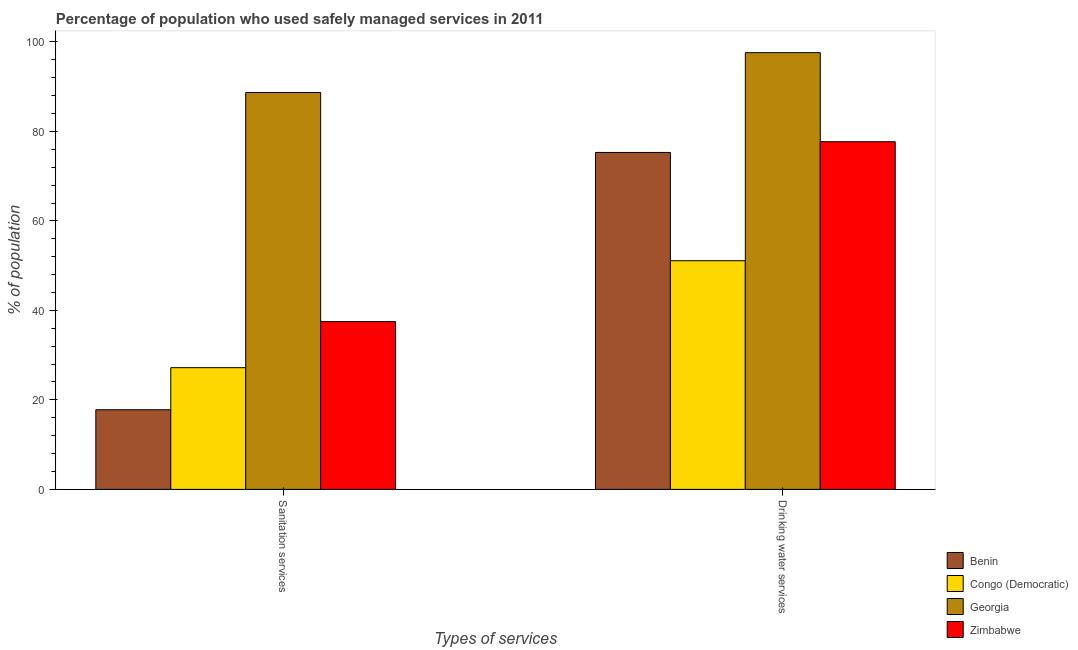Are the number of bars per tick equal to the number of legend labels?
Offer a terse response. Yes. Are the number of bars on each tick of the X-axis equal?
Ensure brevity in your answer.  Yes. How many bars are there on the 1st tick from the left?
Provide a succinct answer. 4. What is the label of the 2nd group of bars from the left?
Offer a terse response. Drinking water services. What is the percentage of population who used sanitation services in Congo (Democratic)?
Give a very brief answer. 27.2. Across all countries, what is the maximum percentage of population who used sanitation services?
Provide a short and direct response. 88.7. In which country was the percentage of population who used sanitation services maximum?
Your answer should be compact. Georgia. In which country was the percentage of population who used drinking water services minimum?
Your response must be concise. Congo (Democratic). What is the total percentage of population who used drinking water services in the graph?
Offer a very short reply. 301.7. What is the difference between the percentage of population who used drinking water services in Congo (Democratic) and that in Georgia?
Offer a very short reply. -46.5. What is the difference between the percentage of population who used sanitation services in Zimbabwe and the percentage of population who used drinking water services in Congo (Democratic)?
Keep it short and to the point. -13.6. What is the average percentage of population who used sanitation services per country?
Offer a very short reply. 42.8. What is the difference between the percentage of population who used drinking water services and percentage of population who used sanitation services in Zimbabwe?
Your answer should be very brief. 40.2. In how many countries, is the percentage of population who used sanitation services greater than 52 %?
Make the answer very short. 1. What is the ratio of the percentage of population who used drinking water services in Congo (Democratic) to that in Georgia?
Offer a terse response. 0.52. Is the percentage of population who used sanitation services in Congo (Democratic) less than that in Georgia?
Ensure brevity in your answer.  Yes. What does the 2nd bar from the left in Drinking water services represents?
Your response must be concise. Congo (Democratic). What does the 4th bar from the right in Sanitation services represents?
Make the answer very short. Benin. What is the difference between two consecutive major ticks on the Y-axis?
Offer a very short reply. 20. Are the values on the major ticks of Y-axis written in scientific E-notation?
Offer a terse response. No. Does the graph contain any zero values?
Give a very brief answer. No. How are the legend labels stacked?
Make the answer very short. Vertical. What is the title of the graph?
Your response must be concise. Percentage of population who used safely managed services in 2011. Does "Sweden" appear as one of the legend labels in the graph?
Your answer should be compact. No. What is the label or title of the X-axis?
Ensure brevity in your answer.  Types of services. What is the label or title of the Y-axis?
Keep it short and to the point. % of population. What is the % of population in Benin in Sanitation services?
Your answer should be very brief. 17.8. What is the % of population of Congo (Democratic) in Sanitation services?
Ensure brevity in your answer.  27.2. What is the % of population of Georgia in Sanitation services?
Offer a very short reply. 88.7. What is the % of population in Zimbabwe in Sanitation services?
Ensure brevity in your answer.  37.5. What is the % of population of Benin in Drinking water services?
Your response must be concise. 75.3. What is the % of population of Congo (Democratic) in Drinking water services?
Provide a succinct answer. 51.1. What is the % of population in Georgia in Drinking water services?
Your response must be concise. 97.6. What is the % of population in Zimbabwe in Drinking water services?
Your answer should be compact. 77.7. Across all Types of services, what is the maximum % of population in Benin?
Your response must be concise. 75.3. Across all Types of services, what is the maximum % of population in Congo (Democratic)?
Give a very brief answer. 51.1. Across all Types of services, what is the maximum % of population in Georgia?
Make the answer very short. 97.6. Across all Types of services, what is the maximum % of population of Zimbabwe?
Ensure brevity in your answer.  77.7. Across all Types of services, what is the minimum % of population of Benin?
Make the answer very short. 17.8. Across all Types of services, what is the minimum % of population of Congo (Democratic)?
Keep it short and to the point. 27.2. Across all Types of services, what is the minimum % of population of Georgia?
Provide a succinct answer. 88.7. Across all Types of services, what is the minimum % of population of Zimbabwe?
Offer a very short reply. 37.5. What is the total % of population of Benin in the graph?
Make the answer very short. 93.1. What is the total % of population in Congo (Democratic) in the graph?
Provide a short and direct response. 78.3. What is the total % of population in Georgia in the graph?
Keep it short and to the point. 186.3. What is the total % of population in Zimbabwe in the graph?
Offer a very short reply. 115.2. What is the difference between the % of population of Benin in Sanitation services and that in Drinking water services?
Offer a very short reply. -57.5. What is the difference between the % of population of Congo (Democratic) in Sanitation services and that in Drinking water services?
Ensure brevity in your answer.  -23.9. What is the difference between the % of population of Zimbabwe in Sanitation services and that in Drinking water services?
Offer a terse response. -40.2. What is the difference between the % of population in Benin in Sanitation services and the % of population in Congo (Democratic) in Drinking water services?
Offer a very short reply. -33.3. What is the difference between the % of population of Benin in Sanitation services and the % of population of Georgia in Drinking water services?
Keep it short and to the point. -79.8. What is the difference between the % of population of Benin in Sanitation services and the % of population of Zimbabwe in Drinking water services?
Provide a short and direct response. -59.9. What is the difference between the % of population of Congo (Democratic) in Sanitation services and the % of population of Georgia in Drinking water services?
Your answer should be very brief. -70.4. What is the difference between the % of population of Congo (Democratic) in Sanitation services and the % of population of Zimbabwe in Drinking water services?
Your response must be concise. -50.5. What is the average % of population in Benin per Types of services?
Offer a terse response. 46.55. What is the average % of population of Congo (Democratic) per Types of services?
Ensure brevity in your answer.  39.15. What is the average % of population in Georgia per Types of services?
Make the answer very short. 93.15. What is the average % of population of Zimbabwe per Types of services?
Your response must be concise. 57.6. What is the difference between the % of population in Benin and % of population in Congo (Democratic) in Sanitation services?
Give a very brief answer. -9.4. What is the difference between the % of population in Benin and % of population in Georgia in Sanitation services?
Your answer should be compact. -70.9. What is the difference between the % of population of Benin and % of population of Zimbabwe in Sanitation services?
Make the answer very short. -19.7. What is the difference between the % of population of Congo (Democratic) and % of population of Georgia in Sanitation services?
Make the answer very short. -61.5. What is the difference between the % of population of Georgia and % of population of Zimbabwe in Sanitation services?
Your answer should be compact. 51.2. What is the difference between the % of population in Benin and % of population in Congo (Democratic) in Drinking water services?
Provide a succinct answer. 24.2. What is the difference between the % of population in Benin and % of population in Georgia in Drinking water services?
Offer a terse response. -22.3. What is the difference between the % of population of Benin and % of population of Zimbabwe in Drinking water services?
Your answer should be compact. -2.4. What is the difference between the % of population of Congo (Democratic) and % of population of Georgia in Drinking water services?
Provide a short and direct response. -46.5. What is the difference between the % of population in Congo (Democratic) and % of population in Zimbabwe in Drinking water services?
Your answer should be compact. -26.6. What is the difference between the % of population in Georgia and % of population in Zimbabwe in Drinking water services?
Your response must be concise. 19.9. What is the ratio of the % of population in Benin in Sanitation services to that in Drinking water services?
Give a very brief answer. 0.24. What is the ratio of the % of population in Congo (Democratic) in Sanitation services to that in Drinking water services?
Offer a very short reply. 0.53. What is the ratio of the % of population in Georgia in Sanitation services to that in Drinking water services?
Ensure brevity in your answer.  0.91. What is the ratio of the % of population in Zimbabwe in Sanitation services to that in Drinking water services?
Offer a terse response. 0.48. What is the difference between the highest and the second highest % of population in Benin?
Keep it short and to the point. 57.5. What is the difference between the highest and the second highest % of population of Congo (Democratic)?
Your answer should be very brief. 23.9. What is the difference between the highest and the second highest % of population in Georgia?
Offer a very short reply. 8.9. What is the difference between the highest and the second highest % of population in Zimbabwe?
Give a very brief answer. 40.2. What is the difference between the highest and the lowest % of population in Benin?
Provide a short and direct response. 57.5. What is the difference between the highest and the lowest % of population in Congo (Democratic)?
Provide a short and direct response. 23.9. What is the difference between the highest and the lowest % of population of Georgia?
Your answer should be very brief. 8.9. What is the difference between the highest and the lowest % of population of Zimbabwe?
Provide a succinct answer. 40.2. 